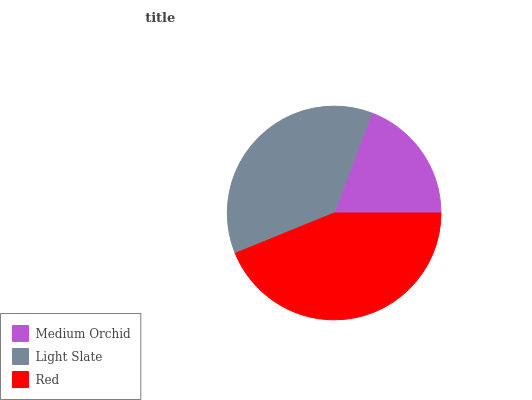Is Medium Orchid the minimum?
Answer yes or no. Yes. Is Red the maximum?
Answer yes or no. Yes. Is Light Slate the minimum?
Answer yes or no. No. Is Light Slate the maximum?
Answer yes or no. No. Is Light Slate greater than Medium Orchid?
Answer yes or no. Yes. Is Medium Orchid less than Light Slate?
Answer yes or no. Yes. Is Medium Orchid greater than Light Slate?
Answer yes or no. No. Is Light Slate less than Medium Orchid?
Answer yes or no. No. Is Light Slate the high median?
Answer yes or no. Yes. Is Light Slate the low median?
Answer yes or no. Yes. Is Red the high median?
Answer yes or no. No. Is Red the low median?
Answer yes or no. No. 